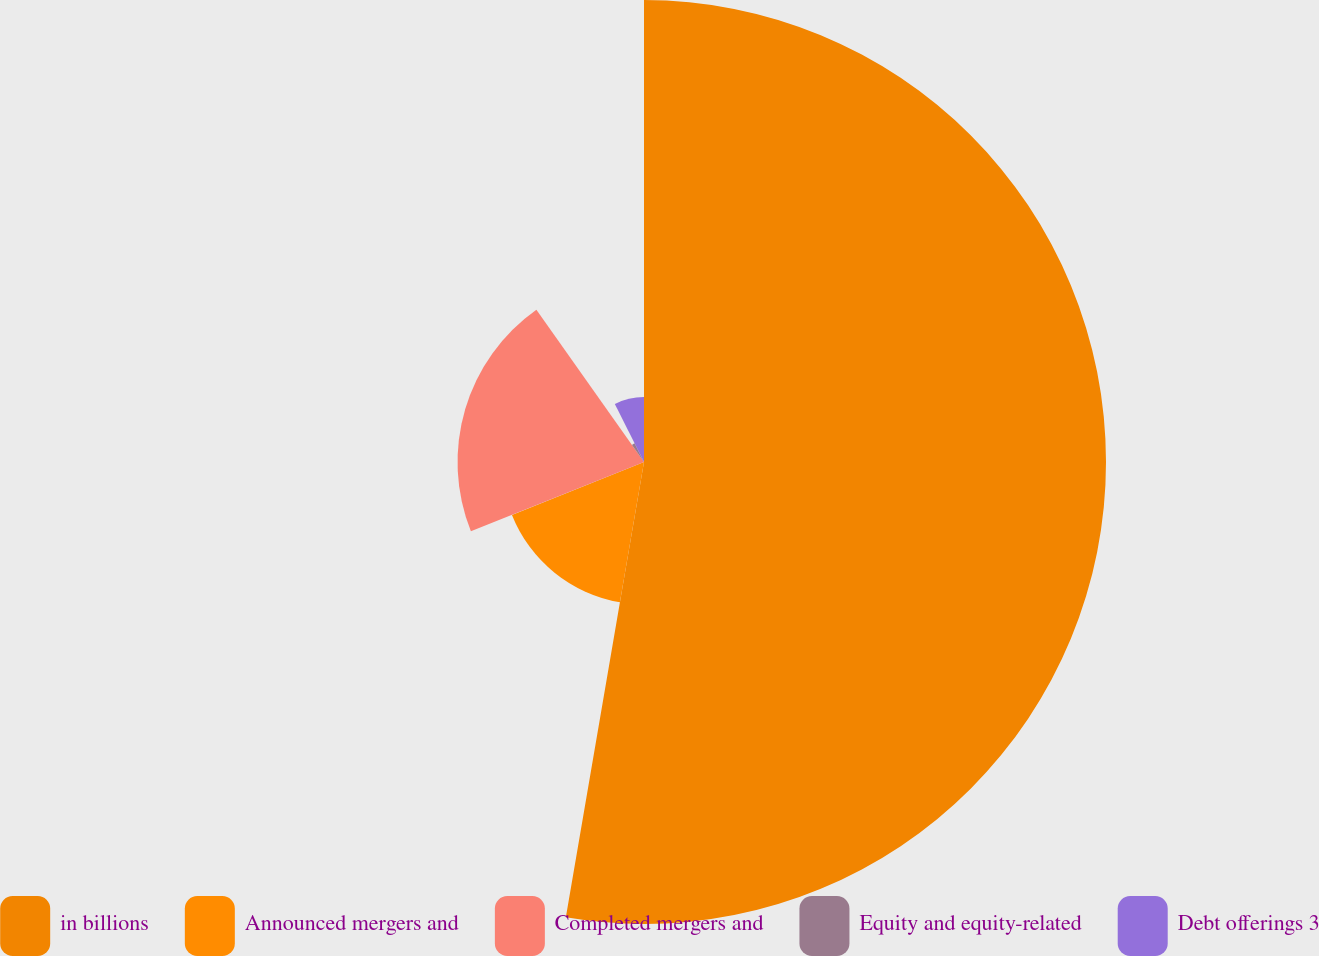Convert chart. <chart><loc_0><loc_0><loc_500><loc_500><pie_chart><fcel>in billions<fcel>Announced mergers and<fcel>Completed mergers and<fcel>Equity and equity-related<fcel>Debt offerings 3<nl><fcel>52.7%<fcel>16.23%<fcel>21.27%<fcel>2.38%<fcel>7.41%<nl></chart> 